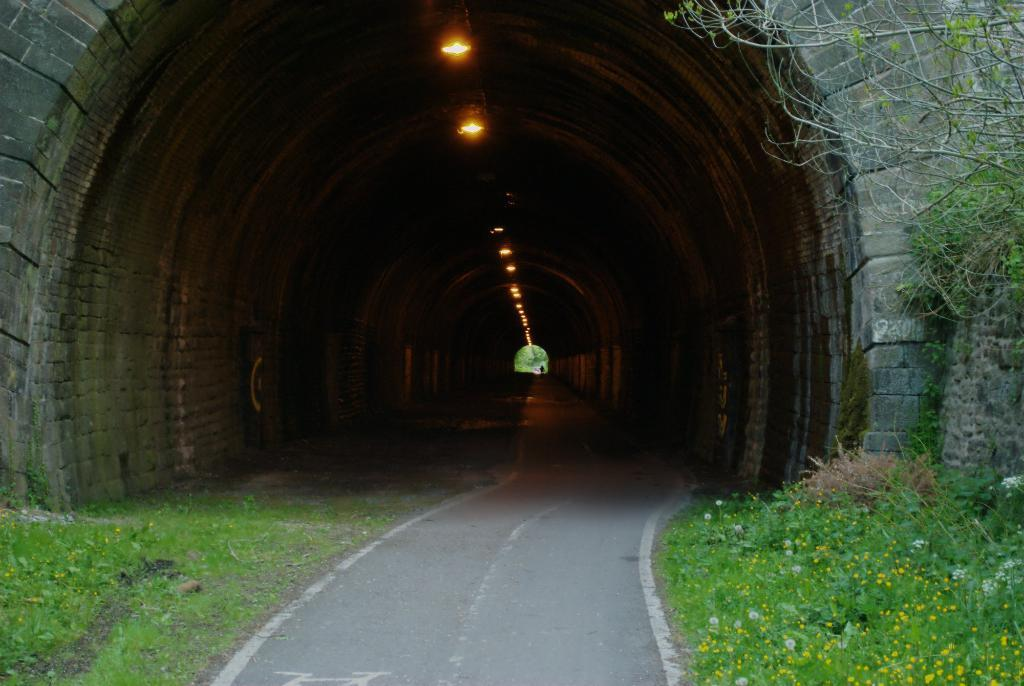What is the main feature of the image? There is a road in the image. Where is the road located? The road is under a tunnel. What can be seen at the top of the image? There are lights visible at the top of the image. What type of vegetation is on the right side of the image? There are plants on the right side of the image. What type of vegetation is on the left side of the image? There are trees on the left side of the image. What type of polish is being applied to the tail of the bird in the image? There is no bird or polish present in the image. Where is the nest of the bird in the image? There is no bird or nest present in the image. 